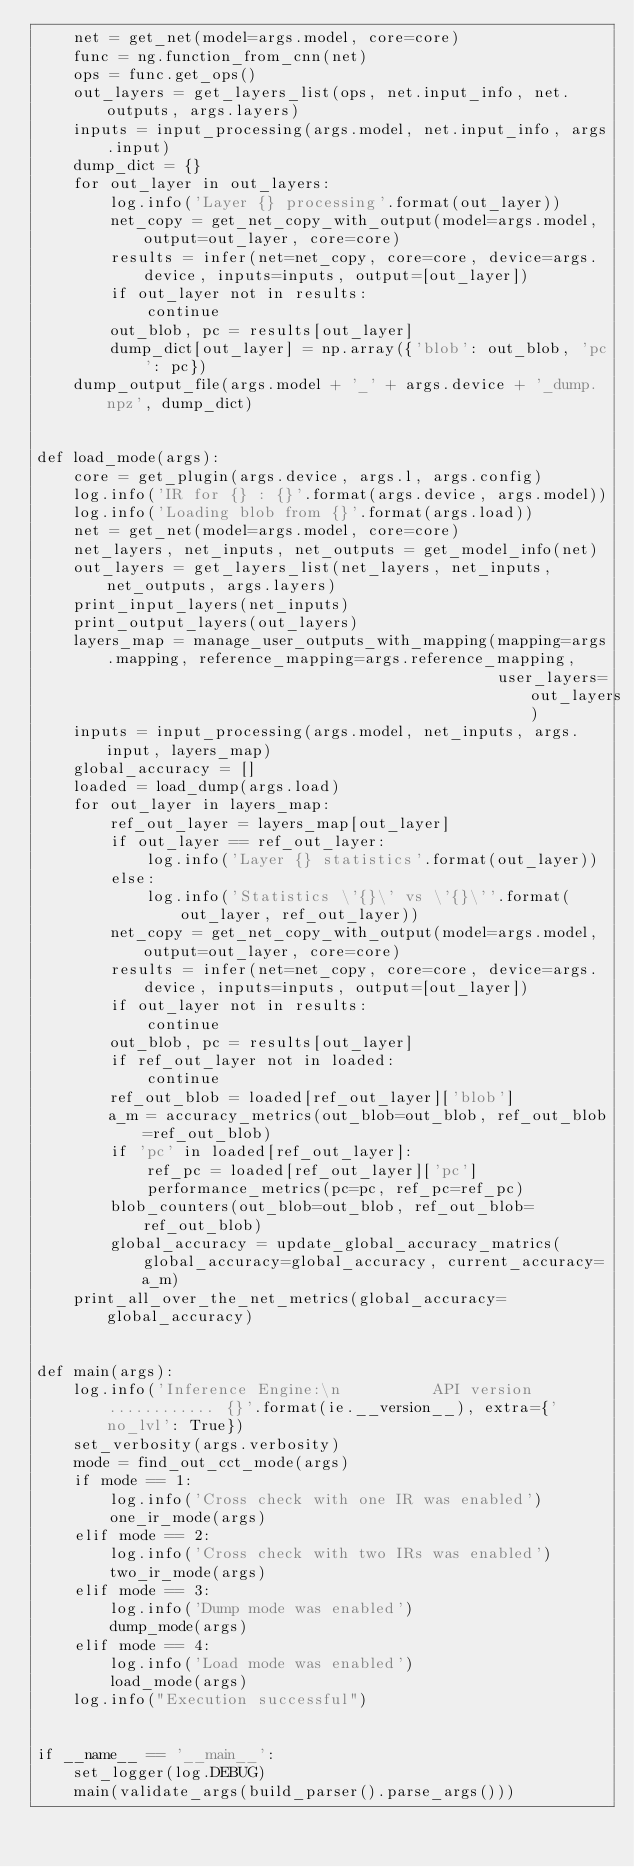Convert code to text. <code><loc_0><loc_0><loc_500><loc_500><_Python_>    net = get_net(model=args.model, core=core)
    func = ng.function_from_cnn(net)
    ops = func.get_ops()
    out_layers = get_layers_list(ops, net.input_info, net.outputs, args.layers)
    inputs = input_processing(args.model, net.input_info, args.input)
    dump_dict = {}
    for out_layer in out_layers:
        log.info('Layer {} processing'.format(out_layer))
        net_copy = get_net_copy_with_output(model=args.model, output=out_layer, core=core)
        results = infer(net=net_copy, core=core, device=args.device, inputs=inputs, output=[out_layer])
        if out_layer not in results:
            continue
        out_blob, pc = results[out_layer]
        dump_dict[out_layer] = np.array({'blob': out_blob, 'pc': pc})
    dump_output_file(args.model + '_' + args.device + '_dump.npz', dump_dict)


def load_mode(args):
    core = get_plugin(args.device, args.l, args.config)
    log.info('IR for {} : {}'.format(args.device, args.model))
    log.info('Loading blob from {}'.format(args.load))
    net = get_net(model=args.model, core=core)
    net_layers, net_inputs, net_outputs = get_model_info(net)
    out_layers = get_layers_list(net_layers, net_inputs, net_outputs, args.layers)
    print_input_layers(net_inputs)
    print_output_layers(out_layers)
    layers_map = manage_user_outputs_with_mapping(mapping=args.mapping, reference_mapping=args.reference_mapping,
                                                  user_layers=out_layers)
    inputs = input_processing(args.model, net_inputs, args.input, layers_map)
    global_accuracy = []
    loaded = load_dump(args.load)
    for out_layer in layers_map:
        ref_out_layer = layers_map[out_layer]
        if out_layer == ref_out_layer:
            log.info('Layer {} statistics'.format(out_layer))
        else:
            log.info('Statistics \'{}\' vs \'{}\''.format(out_layer, ref_out_layer))
        net_copy = get_net_copy_with_output(model=args.model, output=out_layer, core=core)
        results = infer(net=net_copy, core=core, device=args.device, inputs=inputs, output=[out_layer])
        if out_layer not in results:
            continue
        out_blob, pc = results[out_layer]
        if ref_out_layer not in loaded:
            continue
        ref_out_blob = loaded[ref_out_layer]['blob']
        a_m = accuracy_metrics(out_blob=out_blob, ref_out_blob=ref_out_blob)
        if 'pc' in loaded[ref_out_layer]:
            ref_pc = loaded[ref_out_layer]['pc']
            performance_metrics(pc=pc, ref_pc=ref_pc)
        blob_counters(out_blob=out_blob, ref_out_blob=ref_out_blob)
        global_accuracy = update_global_accuracy_matrics(global_accuracy=global_accuracy, current_accuracy=a_m)
    print_all_over_the_net_metrics(global_accuracy=global_accuracy)


def main(args):
    log.info('Inference Engine:\n          API version ............ {}'.format(ie.__version__), extra={'no_lvl': True})
    set_verbosity(args.verbosity)
    mode = find_out_cct_mode(args)
    if mode == 1:
        log.info('Cross check with one IR was enabled')
        one_ir_mode(args)
    elif mode == 2:
        log.info('Cross check with two IRs was enabled')
        two_ir_mode(args)
    elif mode == 3:
        log.info('Dump mode was enabled')
        dump_mode(args)
    elif mode == 4:
        log.info('Load mode was enabled')
        load_mode(args)
    log.info("Execution successful")


if __name__ == '__main__':
    set_logger(log.DEBUG)
    main(validate_args(build_parser().parse_args()))
</code> 